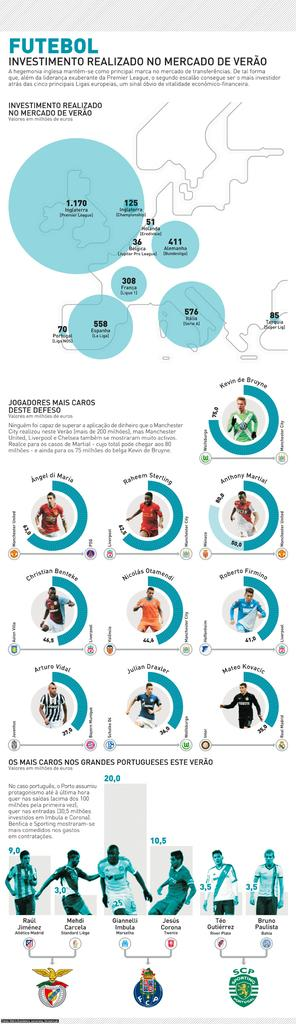What type of visual is the image? The image is a poster. What can be found on the poster besides the visual elements? There is text on the poster. Who or what is depicted on the poster? There is a group of people depicted on the poster. Are there any symbols or branding on the poster? Yes, there are logos on the poster. What nation is being represented by the poster? The image does not represent any specific nation; it is a poster with a group of people and logos. Is there any indication of hate or animosity towards a particular group in the poster? There is no indication of hate or animosity towards any group in the poster; it simply depicts a group of people and logos. 